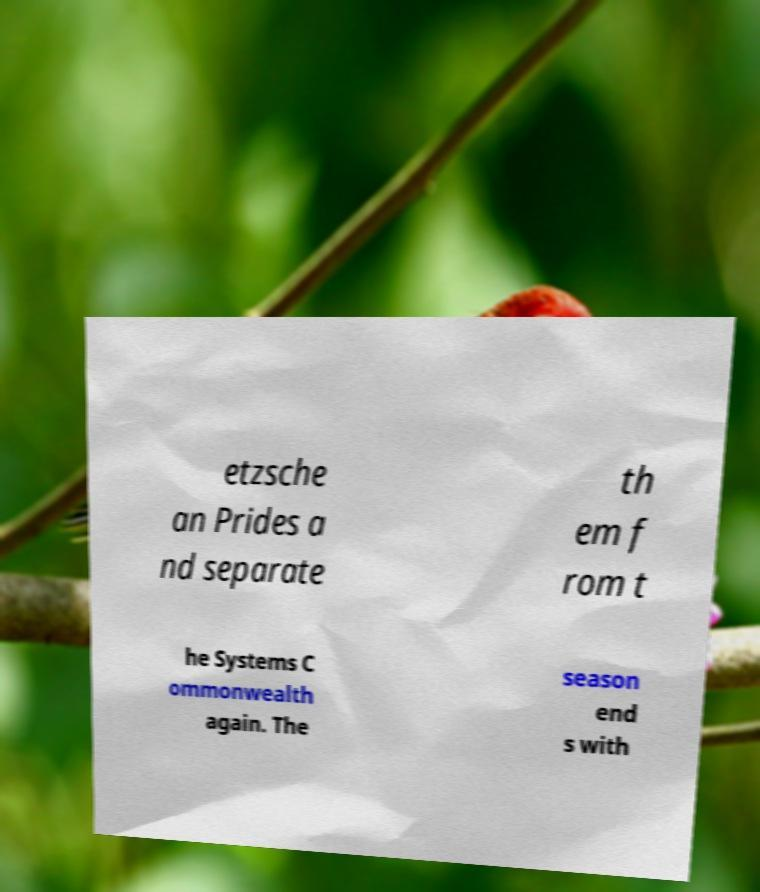Could you extract and type out the text from this image? etzsche an Prides a nd separate th em f rom t he Systems C ommonwealth again. The season end s with 